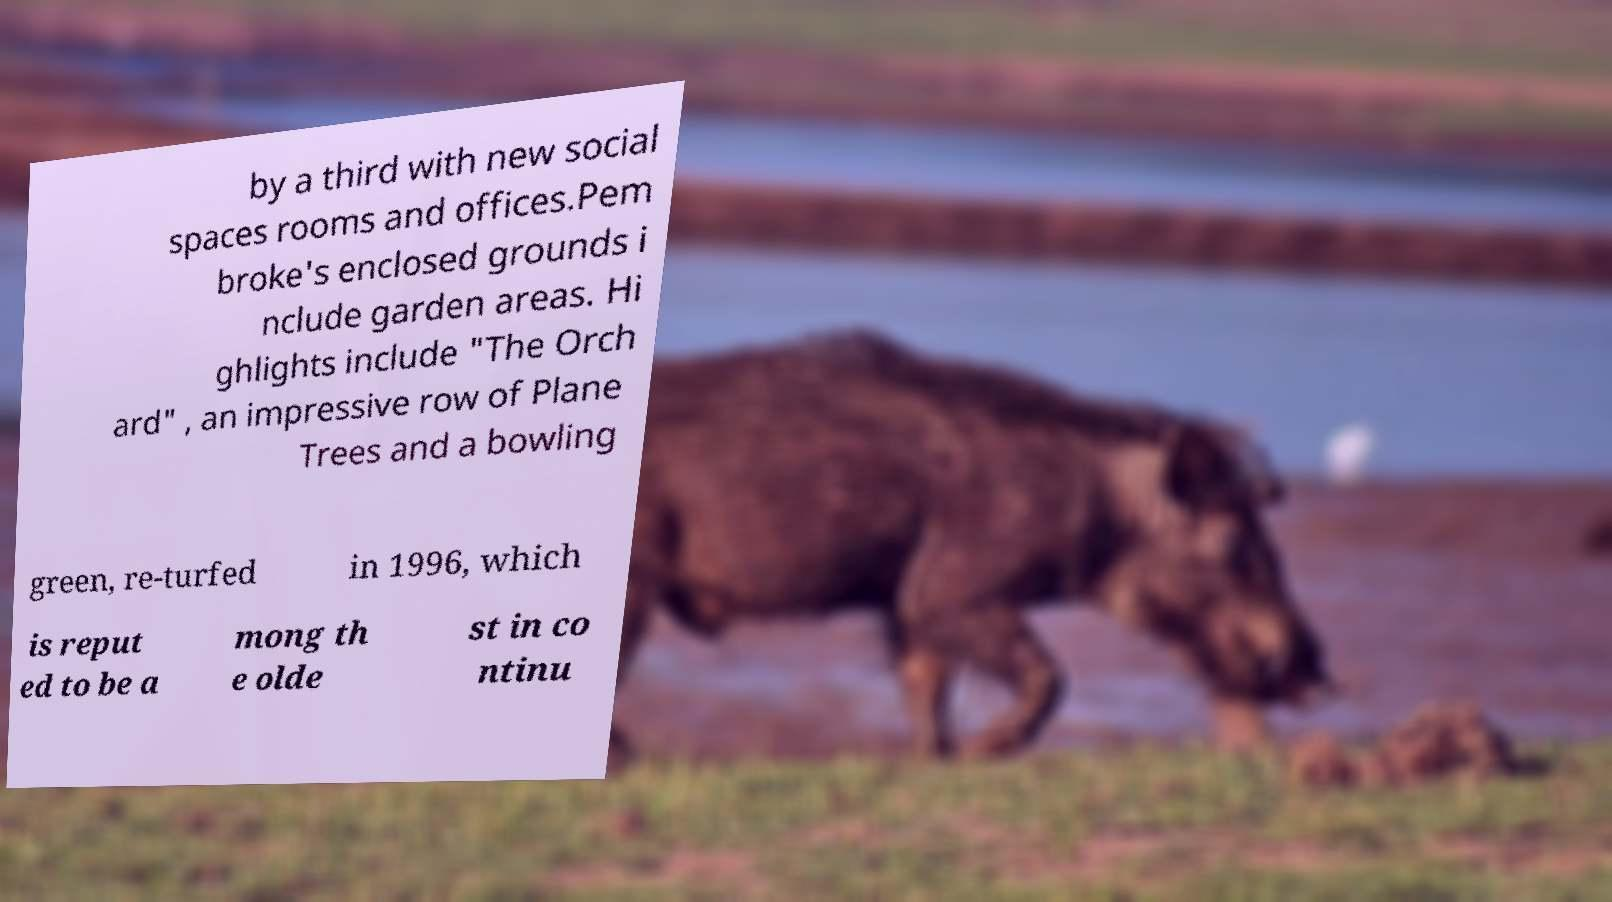Please identify and transcribe the text found in this image. by a third with new social spaces rooms and offices.Pem broke's enclosed grounds i nclude garden areas. Hi ghlights include "The Orch ard" , an impressive row of Plane Trees and a bowling green, re-turfed in 1996, which is reput ed to be a mong th e olde st in co ntinu 